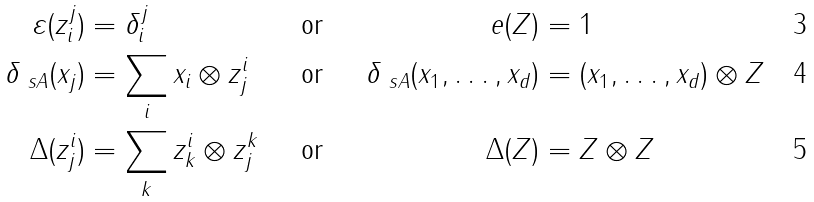Convert formula to latex. <formula><loc_0><loc_0><loc_500><loc_500>\varepsilon ( z ^ { j } _ { i } ) & = \delta ^ { j } _ { i } & & \text {or} & \ e ( Z ) & = 1 \\ \delta _ { \ s A } ( x _ { j } ) & = \sum _ { i } x _ { i } \otimes z ^ { i } _ { j } & & \text {or} & \delta _ { \ s A } ( x _ { 1 } , \dots , x _ { d } ) & = ( x _ { 1 } , \dots , x _ { d } ) \otimes Z \\ \Delta ( z ^ { i } _ { j } ) & = \sum _ { k } z ^ { i } _ { k } \otimes z ^ { k } _ { j } & & \text {or} & \Delta ( Z ) & = Z \otimes Z</formula> 